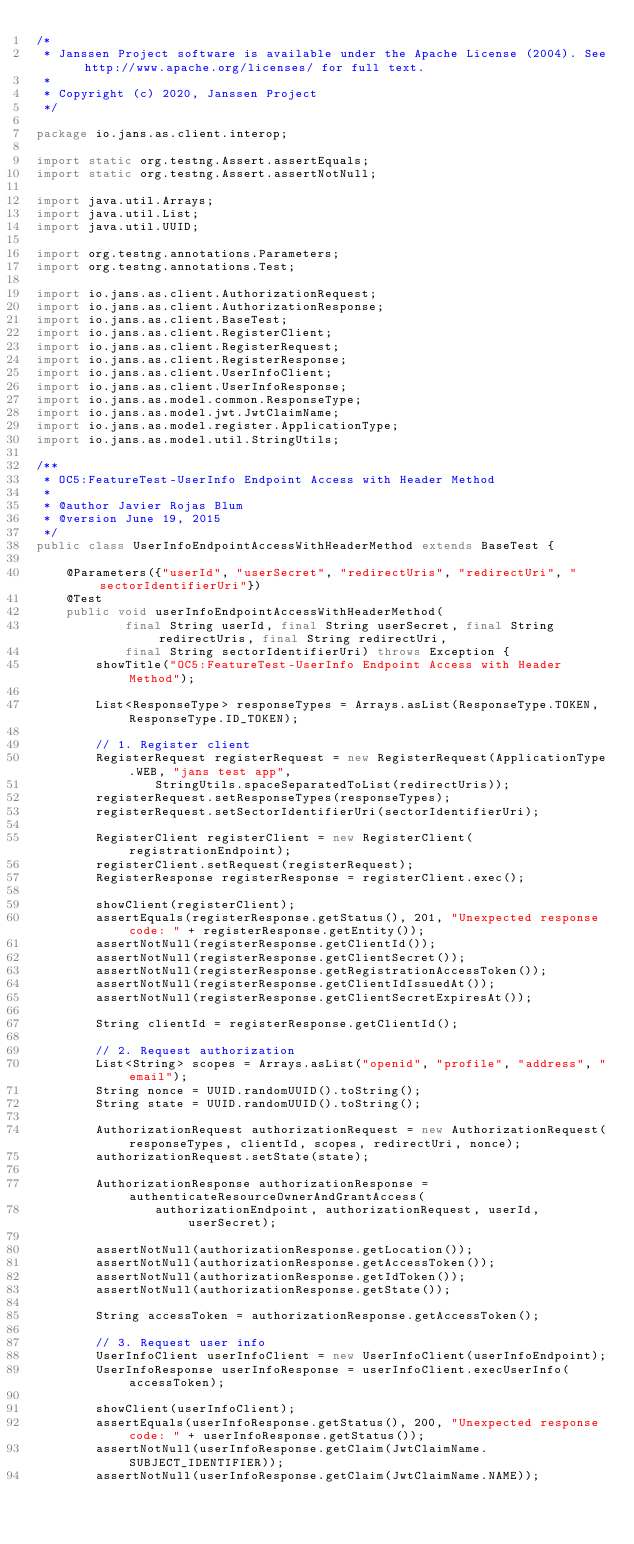Convert code to text. <code><loc_0><loc_0><loc_500><loc_500><_Java_>/*
 * Janssen Project software is available under the Apache License (2004). See http://www.apache.org/licenses/ for full text.
 *
 * Copyright (c) 2020, Janssen Project
 */

package io.jans.as.client.interop;

import static org.testng.Assert.assertEquals;
import static org.testng.Assert.assertNotNull;

import java.util.Arrays;
import java.util.List;
import java.util.UUID;

import org.testng.annotations.Parameters;
import org.testng.annotations.Test;

import io.jans.as.client.AuthorizationRequest;
import io.jans.as.client.AuthorizationResponse;
import io.jans.as.client.BaseTest;
import io.jans.as.client.RegisterClient;
import io.jans.as.client.RegisterRequest;
import io.jans.as.client.RegisterResponse;
import io.jans.as.client.UserInfoClient;
import io.jans.as.client.UserInfoResponse;
import io.jans.as.model.common.ResponseType;
import io.jans.as.model.jwt.JwtClaimName;
import io.jans.as.model.register.ApplicationType;
import io.jans.as.model.util.StringUtils;

/**
 * OC5:FeatureTest-UserInfo Endpoint Access with Header Method
 *
 * @author Javier Rojas Blum
 * @version June 19, 2015
 */
public class UserInfoEndpointAccessWithHeaderMethod extends BaseTest {

    @Parameters({"userId", "userSecret", "redirectUris", "redirectUri", "sectorIdentifierUri"})
    @Test
    public void userInfoEndpointAccessWithHeaderMethod(
            final String userId, final String userSecret, final String redirectUris, final String redirectUri,
            final String sectorIdentifierUri) throws Exception {
        showTitle("OC5:FeatureTest-UserInfo Endpoint Access with Header Method");

        List<ResponseType> responseTypes = Arrays.asList(ResponseType.TOKEN, ResponseType.ID_TOKEN);

        // 1. Register client
        RegisterRequest registerRequest = new RegisterRequest(ApplicationType.WEB, "jans test app",
                StringUtils.spaceSeparatedToList(redirectUris));
        registerRequest.setResponseTypes(responseTypes);
        registerRequest.setSectorIdentifierUri(sectorIdentifierUri);

        RegisterClient registerClient = new RegisterClient(registrationEndpoint);
        registerClient.setRequest(registerRequest);
        RegisterResponse registerResponse = registerClient.exec();

        showClient(registerClient);
        assertEquals(registerResponse.getStatus(), 201, "Unexpected response code: " + registerResponse.getEntity());
        assertNotNull(registerResponse.getClientId());
        assertNotNull(registerResponse.getClientSecret());
        assertNotNull(registerResponse.getRegistrationAccessToken());
        assertNotNull(registerResponse.getClientIdIssuedAt());
        assertNotNull(registerResponse.getClientSecretExpiresAt());

        String clientId = registerResponse.getClientId();

        // 2. Request authorization
        List<String> scopes = Arrays.asList("openid", "profile", "address", "email");
        String nonce = UUID.randomUUID().toString();
        String state = UUID.randomUUID().toString();

        AuthorizationRequest authorizationRequest = new AuthorizationRequest(responseTypes, clientId, scopes, redirectUri, nonce);
        authorizationRequest.setState(state);

        AuthorizationResponse authorizationResponse = authenticateResourceOwnerAndGrantAccess(
                authorizationEndpoint, authorizationRequest, userId, userSecret);

        assertNotNull(authorizationResponse.getLocation());
        assertNotNull(authorizationResponse.getAccessToken());
        assertNotNull(authorizationResponse.getIdToken());
        assertNotNull(authorizationResponse.getState());

        String accessToken = authorizationResponse.getAccessToken();

        // 3. Request user info
        UserInfoClient userInfoClient = new UserInfoClient(userInfoEndpoint);
        UserInfoResponse userInfoResponse = userInfoClient.execUserInfo(accessToken);

        showClient(userInfoClient);
        assertEquals(userInfoResponse.getStatus(), 200, "Unexpected response code: " + userInfoResponse.getStatus());
        assertNotNull(userInfoResponse.getClaim(JwtClaimName.SUBJECT_IDENTIFIER));
        assertNotNull(userInfoResponse.getClaim(JwtClaimName.NAME));</code> 